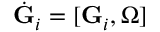Convert formula to latex. <formula><loc_0><loc_0><loc_500><loc_500>\dot { G } _ { i } = [ { G } _ { i } , { \boldsymbol \Omega } ]</formula> 